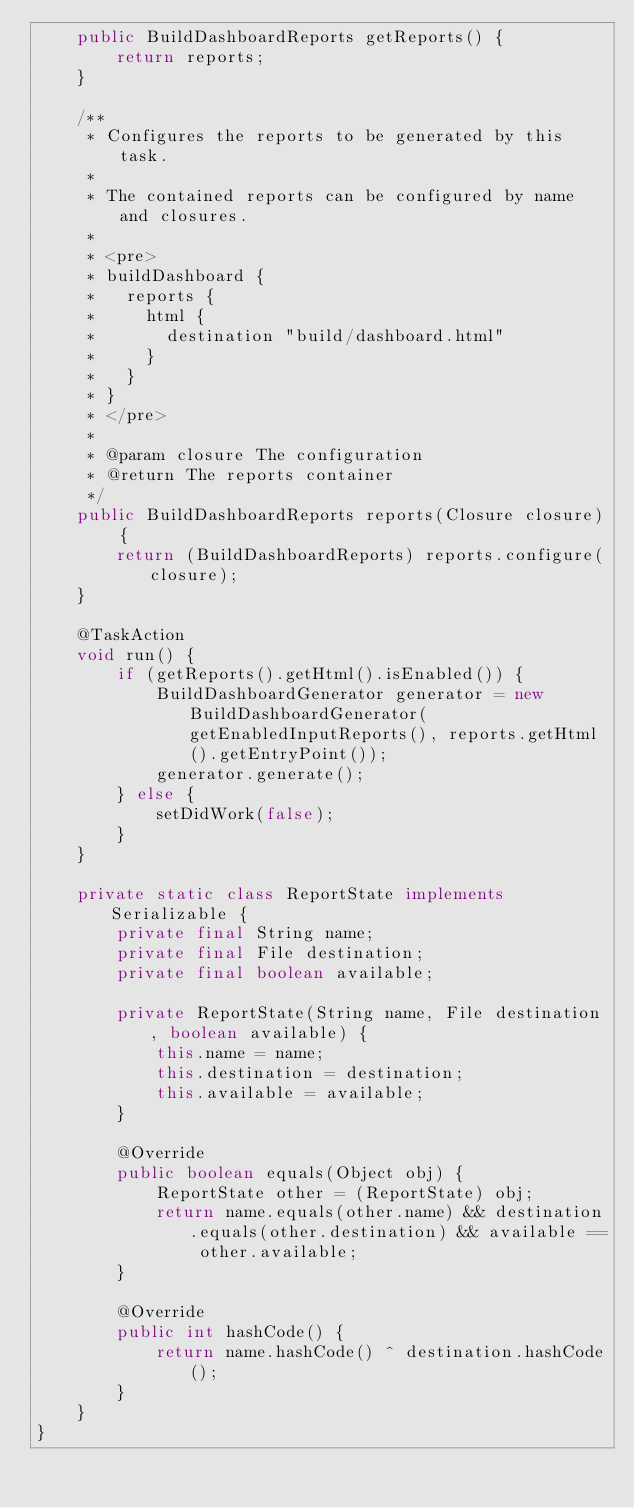<code> <loc_0><loc_0><loc_500><loc_500><_Java_>    public BuildDashboardReports getReports() {
        return reports;
    }

    /**
     * Configures the reports to be generated by this task.
     *
     * The contained reports can be configured by name and closures.
     *
     * <pre>
     * buildDashboard {
     *   reports {
     *     html {
     *       destination "build/dashboard.html"
     *     }
     *   }
     * }
     * </pre>
     *
     * @param closure The configuration
     * @return The reports container
     */
    public BuildDashboardReports reports(Closure closure) {
        return (BuildDashboardReports) reports.configure(closure);
    }

    @TaskAction
    void run() {
        if (getReports().getHtml().isEnabled()) {
            BuildDashboardGenerator generator = new BuildDashboardGenerator(getEnabledInputReports(), reports.getHtml().getEntryPoint());
            generator.generate();
        } else {
            setDidWork(false);
        }
    }

    private static class ReportState implements Serializable {
        private final String name;
        private final File destination;
        private final boolean available;

        private ReportState(String name, File destination, boolean available) {
            this.name = name;
            this.destination = destination;
            this.available = available;
        }

        @Override
        public boolean equals(Object obj) {
            ReportState other = (ReportState) obj;
            return name.equals(other.name) && destination.equals(other.destination) && available == other.available;
        }

        @Override
        public int hashCode() {
            return name.hashCode() ^ destination.hashCode();
        }
    }
}
</code> 